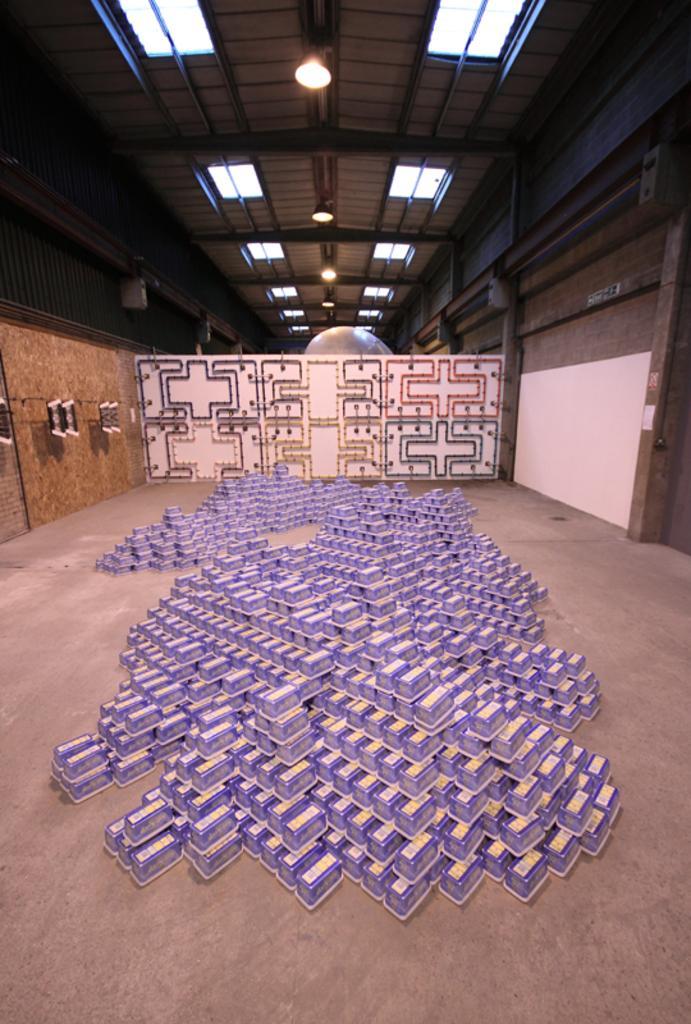Could you give a brief overview of what you see in this image? In this image are few boxes kept one upon the other. They are on the floor. Behind it there is a wall having some design on it. Few lights are attached to the roof. 